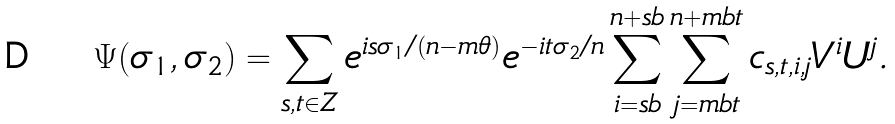Convert formula to latex. <formula><loc_0><loc_0><loc_500><loc_500>\Psi ( \sigma _ { 1 } , \sigma _ { 2 } ) = \sum _ { s , t \in Z } e ^ { i s \sigma _ { 1 } / ( n - m \theta ) } e ^ { - i t \sigma _ { 2 } / n } \sum _ { i = s b } ^ { n + s b } \sum _ { j = m b t } ^ { n + m b t } c _ { s , t , i , j } V ^ { i } U ^ { j } .</formula> 